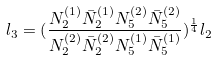Convert formula to latex. <formula><loc_0><loc_0><loc_500><loc_500>l _ { 3 } = ( \frac { N _ { 2 } ^ { ( 1 ) } \bar { N } _ { 2 } ^ { ( 1 ) } N _ { 5 } ^ { ( 2 ) } \bar { N } _ { 5 } ^ { ( 2 ) } } { N _ { 2 } ^ { ( 2 ) } \bar { N } _ { 2 } ^ { ( 2 ) } N _ { 5 } ^ { ( 1 ) } \bar { N } _ { 5 } ^ { ( 1 ) } } ) ^ { \frac { 1 } { 4 } } l _ { 2 }</formula> 